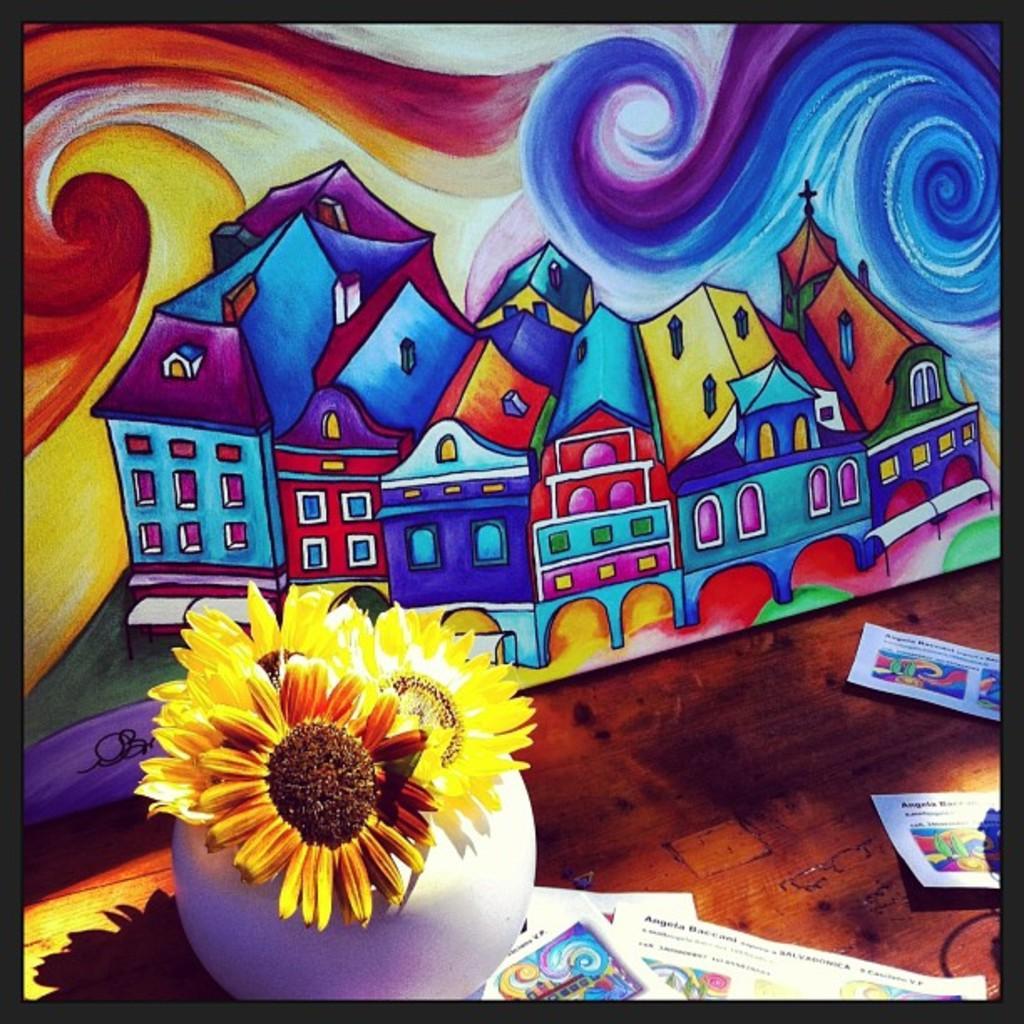Could you give a brief overview of what you see in this image? In this image there is a painting on the wall, beside that there is a table with flower vase and papers. 